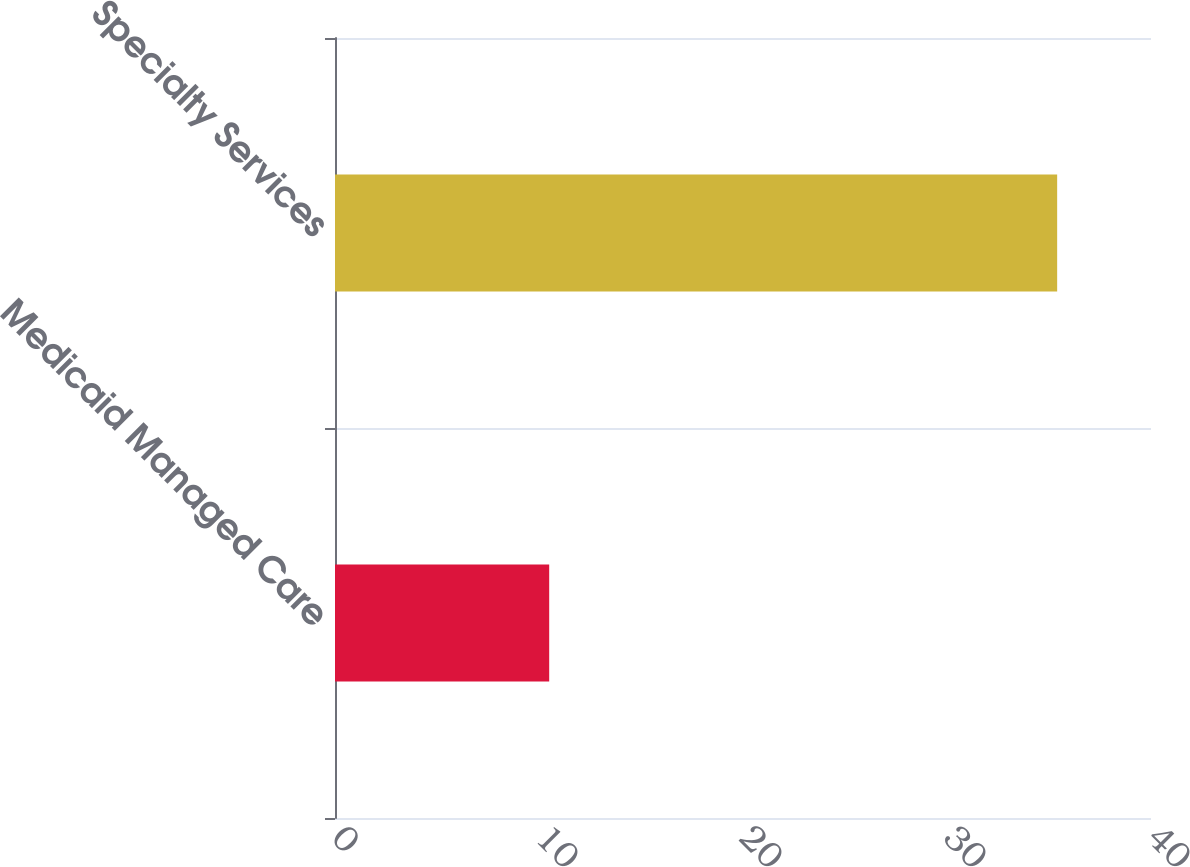<chart> <loc_0><loc_0><loc_500><loc_500><bar_chart><fcel>Medicaid Managed Care<fcel>Specialty Services<nl><fcel>10.5<fcel>35.4<nl></chart> 